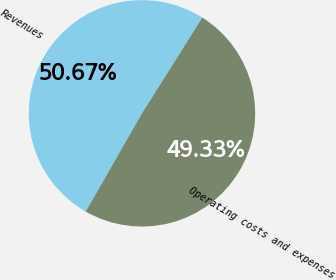<chart> <loc_0><loc_0><loc_500><loc_500><pie_chart><fcel>Revenues<fcel>Operating costs and expenses<nl><fcel>50.67%<fcel>49.33%<nl></chart> 